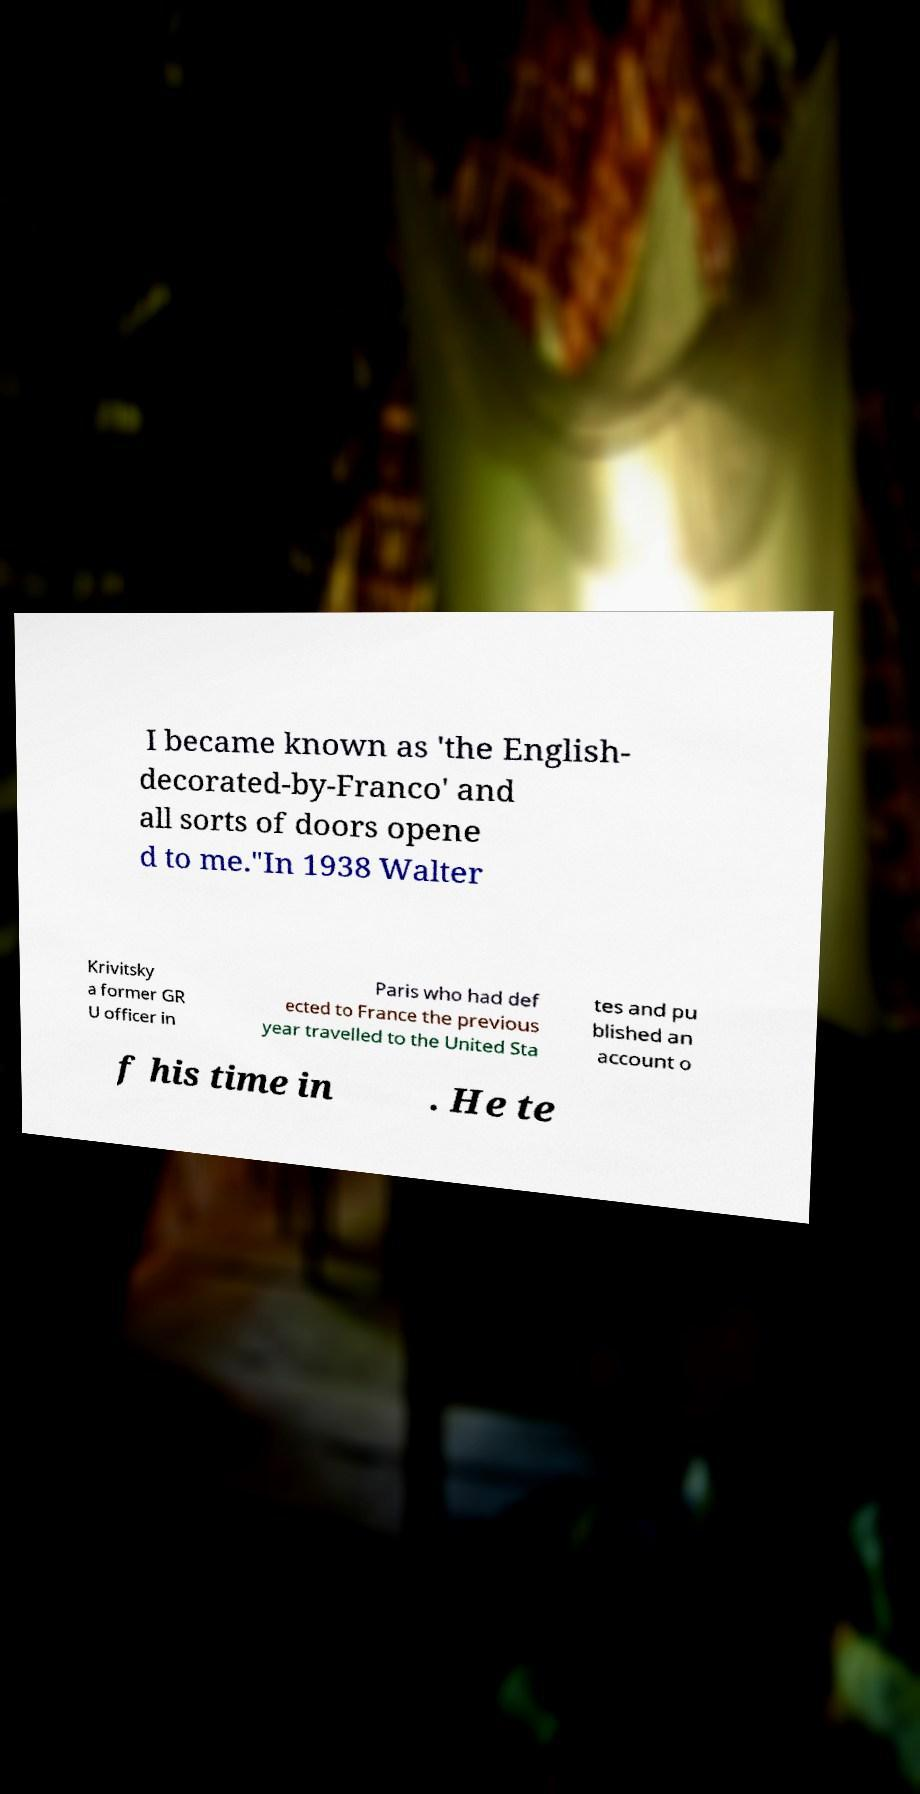Can you read and provide the text displayed in the image?This photo seems to have some interesting text. Can you extract and type it out for me? I became known as 'the English- decorated-by-Franco' and all sorts of doors opene d to me."In 1938 Walter Krivitsky a former GR U officer in Paris who had def ected to France the previous year travelled to the United Sta tes and pu blished an account o f his time in . He te 